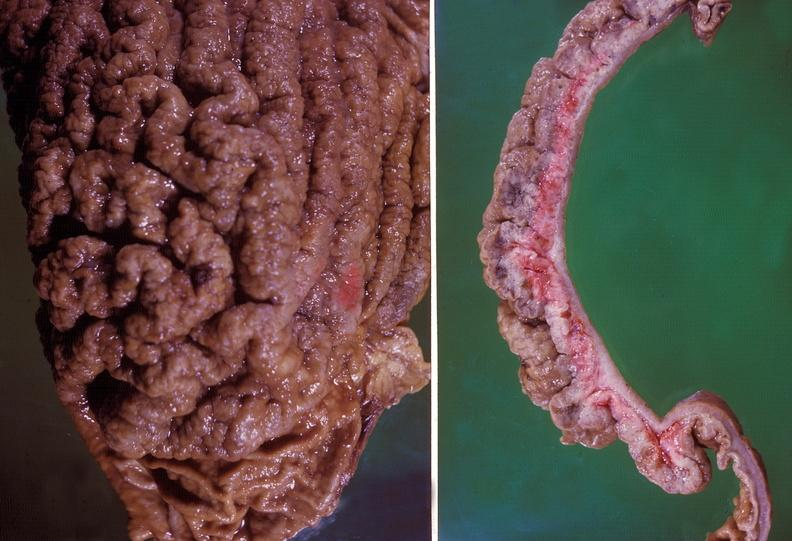where does this belong to?
Answer the question using a single word or phrase. Gastrointestinal system 